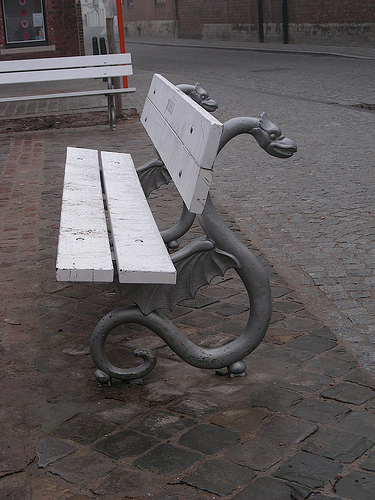<image>
Is there a bench on the ground? Yes. Looking at the image, I can see the bench is positioned on top of the ground, with the ground providing support. 